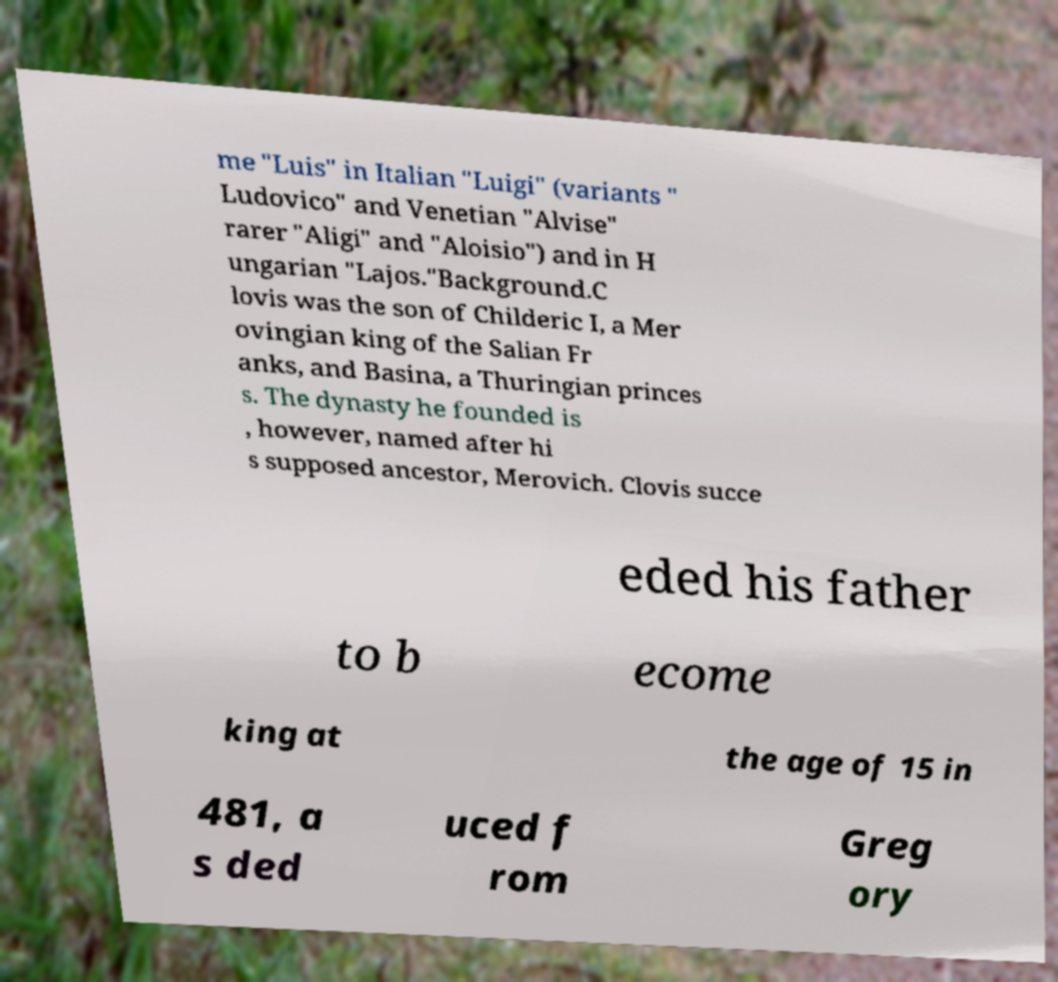Could you extract and type out the text from this image? me "Luis" in Italian "Luigi" (variants " Ludovico" and Venetian "Alvise" rarer "Aligi" and "Aloisio") and in H ungarian "Lajos."Background.C lovis was the son of Childeric I, a Mer ovingian king of the Salian Fr anks, and Basina, a Thuringian princes s. The dynasty he founded is , however, named after hi s supposed ancestor, Merovich. Clovis succe eded his father to b ecome king at the age of 15 in 481, a s ded uced f rom Greg ory 